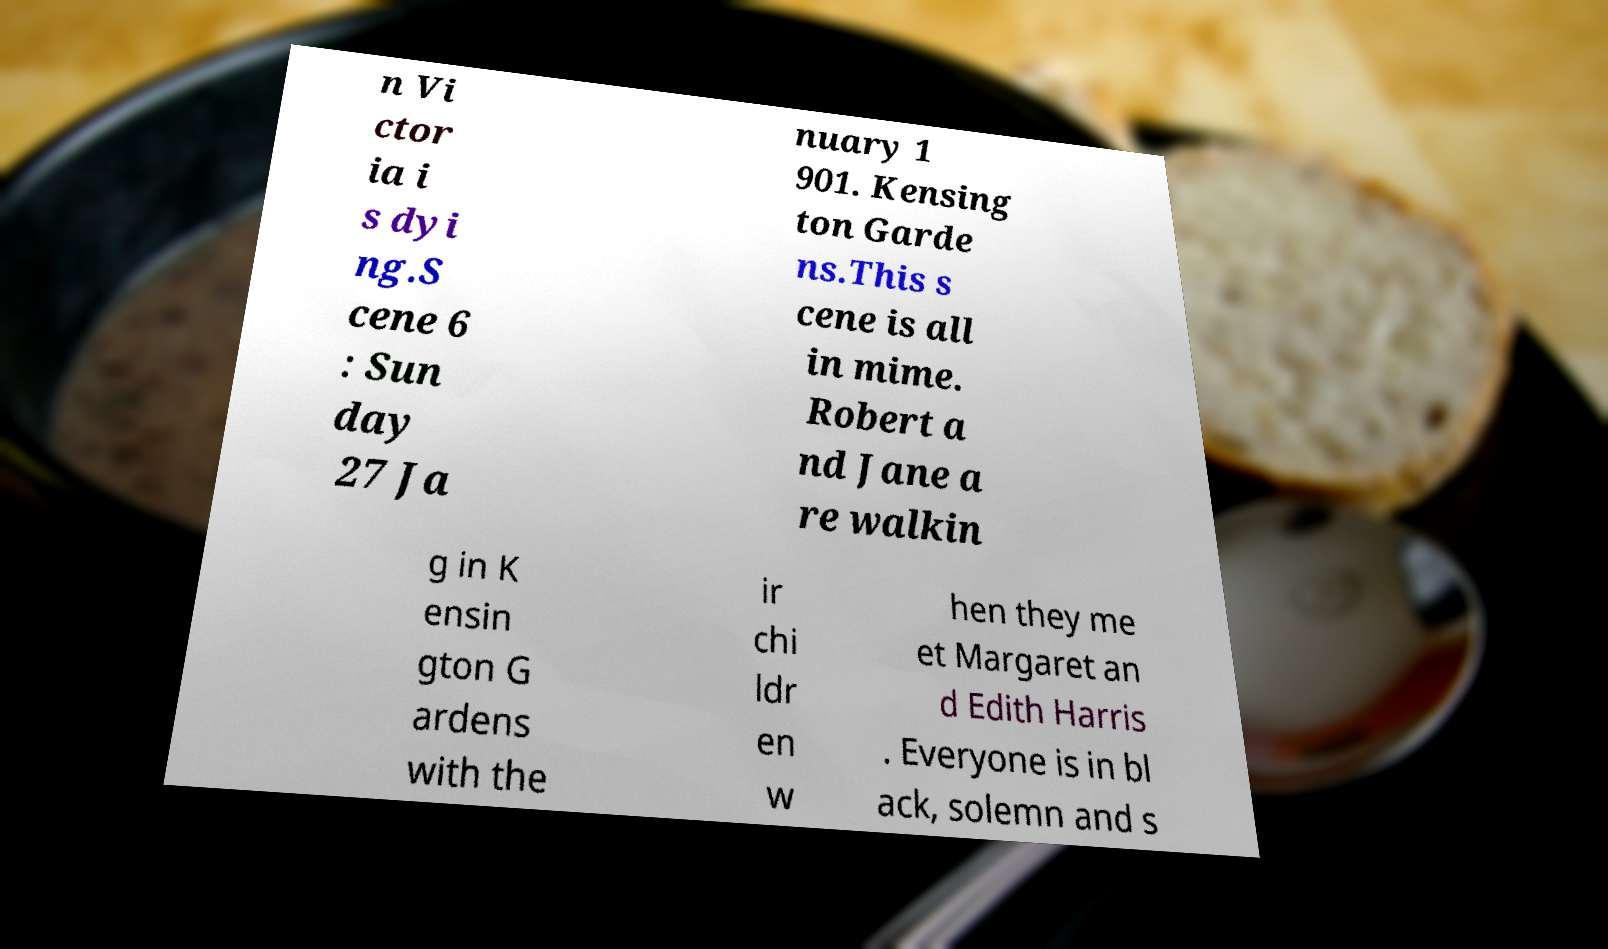There's text embedded in this image that I need extracted. Can you transcribe it verbatim? n Vi ctor ia i s dyi ng.S cene 6 : Sun day 27 Ja nuary 1 901. Kensing ton Garde ns.This s cene is all in mime. Robert a nd Jane a re walkin g in K ensin gton G ardens with the ir chi ldr en w hen they me et Margaret an d Edith Harris . Everyone is in bl ack, solemn and s 